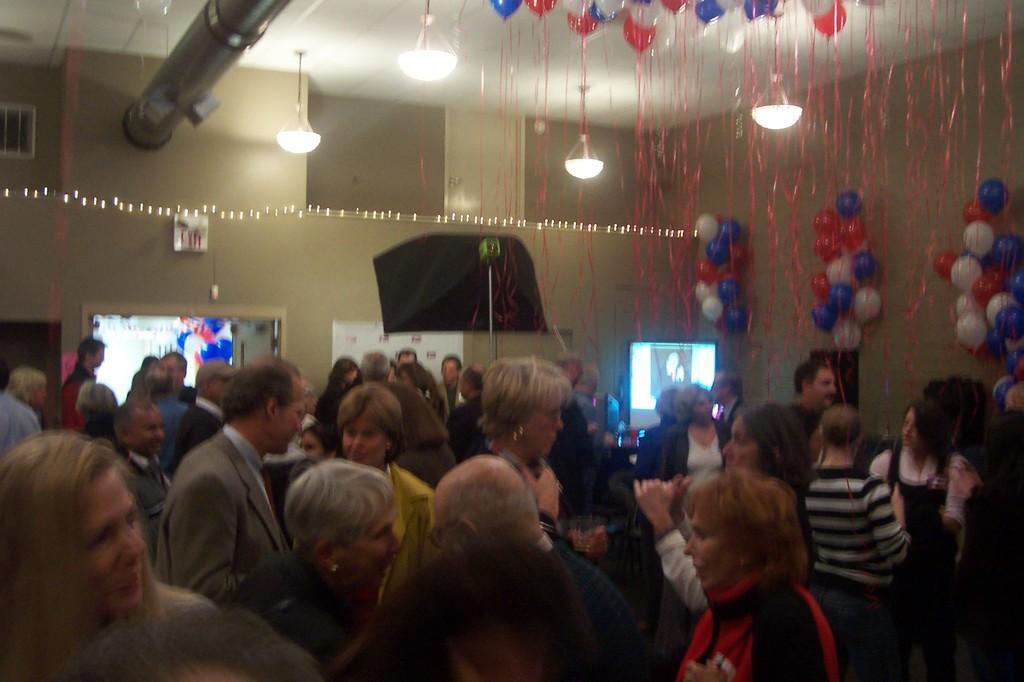Please provide a concise description of this image. In this image there is a crowd at the bottom, in the middle there is the wall, there are balloons, lights hanging, ribbons, pipe line visible at the top of roof and there are some screens and poles visible in the middle and bunch of balloons attached on the right side. 